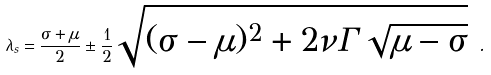Convert formula to latex. <formula><loc_0><loc_0><loc_500><loc_500>\label l { e q \colon k o n e l a m b d a } \lambda _ { s } = \frac { \sigma + \mu } { 2 } \pm \frac { 1 } { 2 } \sqrt { ( \sigma - \mu ) ^ { 2 } + 2 \nu \Gamma \sqrt { \mu - \sigma } } \ .</formula> 